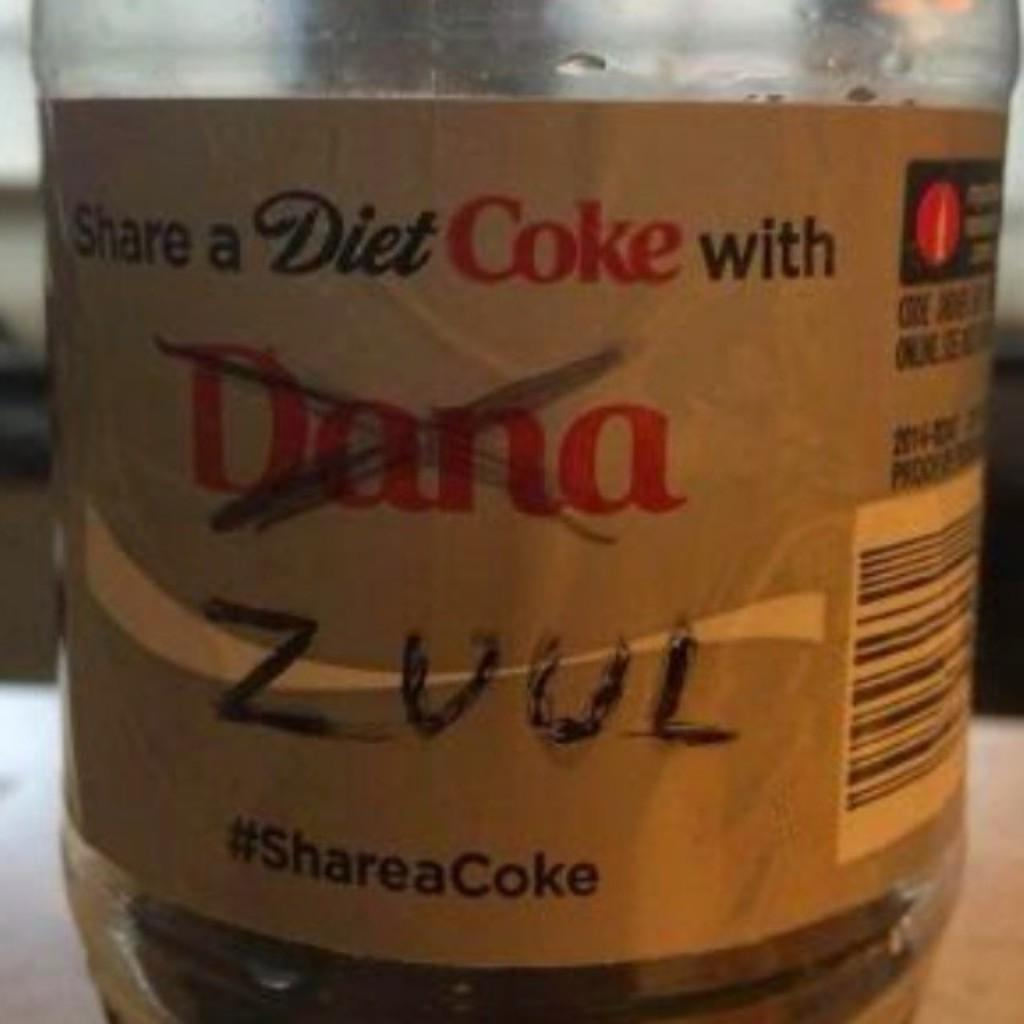<image>
Summarize the visual content of the image. a bottle that says 'share a diet coke with zuul' and 'dana' crossed out 